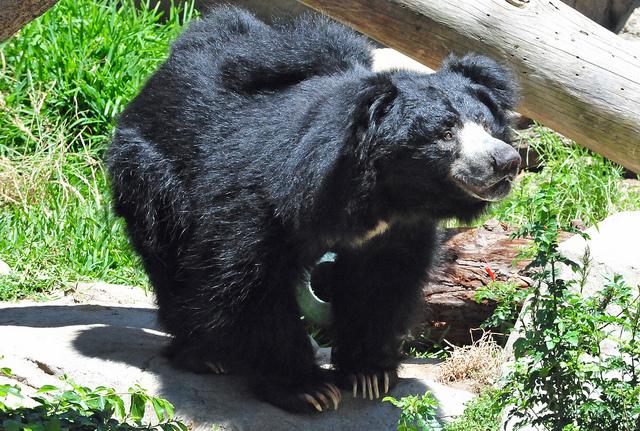Where is a small green pot?
Keep it brief. Behind bear. Is this bear at the zoo?
Short answer required. Yes. Is the bear running?
Short answer required. No. What kind of bear is this?
Be succinct. Black. Are all four paws touching the ground?
Short answer required. Yes. 